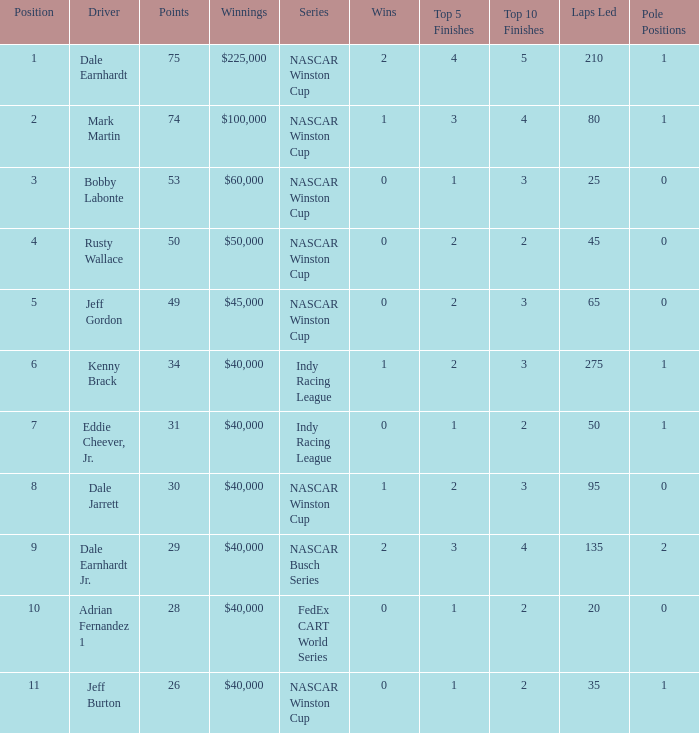In what position was the driver who won $60,000? 3.0. 